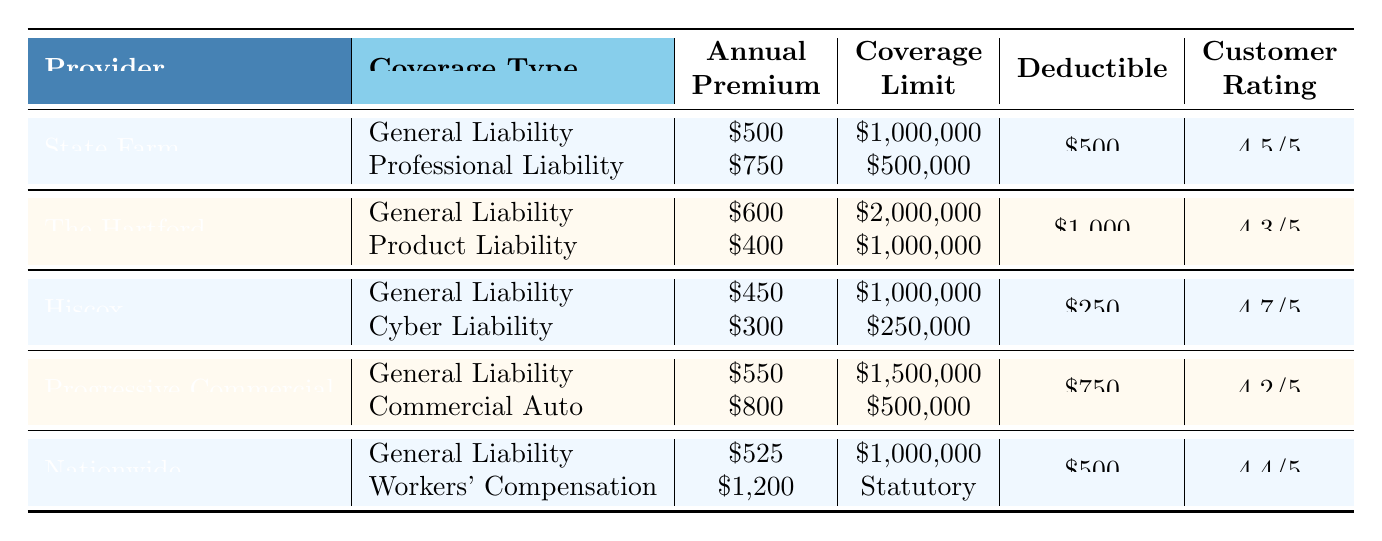What is the annual premium for General Liability from Hiscox? The table lists Hiscox as one of the providers and states that the annual premium for General Liability is $450.
Answer: $450 Who has the highest customer rating? By comparing the customer ratings for each provider, Hiscox has the highest rating of 4.7/5.
Answer: Hiscox What is the total annual premium for Professional Liability and Cyber Liability combined? The annual premium for Professional Liability from State Farm is $750, and for Cyber Liability from Hiscox, it is $300. Adding these two gives $750 + $300 = $1050.
Answer: $1050 Does The Hartford offer a coverage type for Workers' Compensation? The table does not list Workers' Compensation under The Hartford's coverage types, so the answer is no.
Answer: No Which provider has the lowest deductible? The table shows that Hiscox has the lowest deductible at $250.
Answer: Hiscox What is the average annual premium for all providers' General Liability coverage? The annual premiums for General Liability from each provider are $500, $600, $450, $550, and $525. Summing them gives $500 + $600 + $450 + $550 + $525 = $2625. Dividing by 5 gives an average of $525.
Answer: $525 Are there any providers that offer a coverage limit above $2,000,000? The table indicates that The Hartford offers a General Liability coverage limit of $2,000,000, which is the highest listed. Since no other limits exceed this, the answer to this is no.
Answer: No Which provider’s coverage types include Commercial Auto? The table indicates that Progressive Commercial is the provider that includes Commercial Auto in its coverage types.
Answer: Progressive Commercial What is the difference in annual premiums for General Liability between State Farm and Nationwide? The annual premium for General Liability from State Farm is $500 and from Nationwide is $525. The difference is $525 - $500 = $25.
Answer: $25 Which provider offers the highest annual premium for a single coverage type? By examining the premium amounts, Progressive Commercial lists the highest single premium of $800 for Commercial Auto.
Answer: Progressive Commercial 